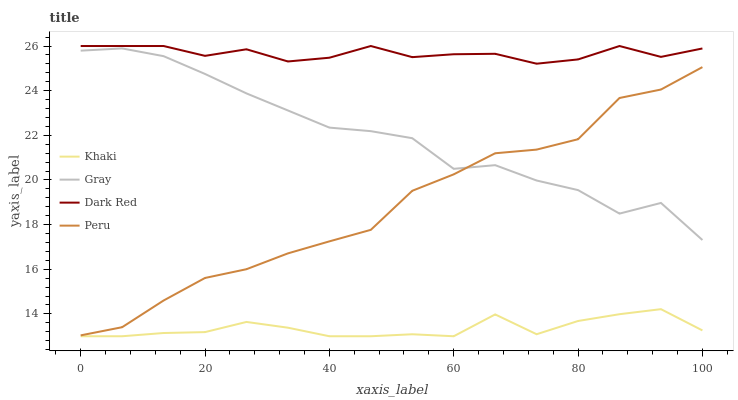Does Peru have the minimum area under the curve?
Answer yes or no. No. Does Peru have the maximum area under the curve?
Answer yes or no. No. Is Peru the smoothest?
Answer yes or no. No. Is Peru the roughest?
Answer yes or no. No. Does Peru have the lowest value?
Answer yes or no. No. Does Peru have the highest value?
Answer yes or no. No. Is Khaki less than Gray?
Answer yes or no. Yes. Is Peru greater than Khaki?
Answer yes or no. Yes. Does Khaki intersect Gray?
Answer yes or no. No. 